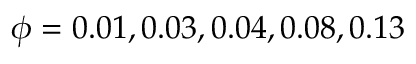<formula> <loc_0><loc_0><loc_500><loc_500>\phi = 0 . 0 1 , 0 . 0 3 , 0 . 0 4 , 0 . 0 8 , 0 . 1 3</formula> 